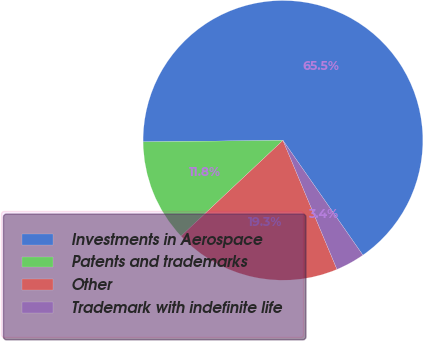Convert chart to OTSL. <chart><loc_0><loc_0><loc_500><loc_500><pie_chart><fcel>Investments in Aerospace<fcel>Patents and trademarks<fcel>Other<fcel>Trademark with indefinite life<nl><fcel>65.48%<fcel>11.84%<fcel>19.31%<fcel>3.37%<nl></chart> 